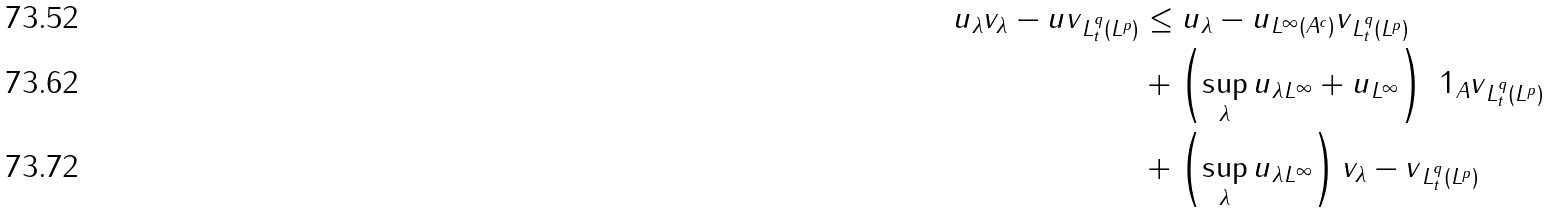Convert formula to latex. <formula><loc_0><loc_0><loc_500><loc_500>\| u _ { \lambda } v _ { \lambda } - u v \| _ { L ^ { q } _ { t } ( L ^ { p } ) } & \leq \| u _ { \lambda } - u \| _ { L ^ { \infty } ( A ^ { c } ) } \| v \| _ { L ^ { q } _ { t } ( L ^ { p } ) } \\ & + \left ( \sup _ { \lambda } \| u _ { \lambda } \| _ { L ^ { \infty } } + \| u \| _ { L ^ { \infty } } \right ) \| \ 1 _ { A } v \| _ { L ^ { q } _ { t } ( L ^ { p } ) } \\ & + \left ( \sup _ { \lambda } \| u _ { \lambda } \| _ { L ^ { \infty } } \right ) \| v _ { \lambda } - v \| _ { L ^ { q } _ { t } ( L ^ { p } ) }</formula> 